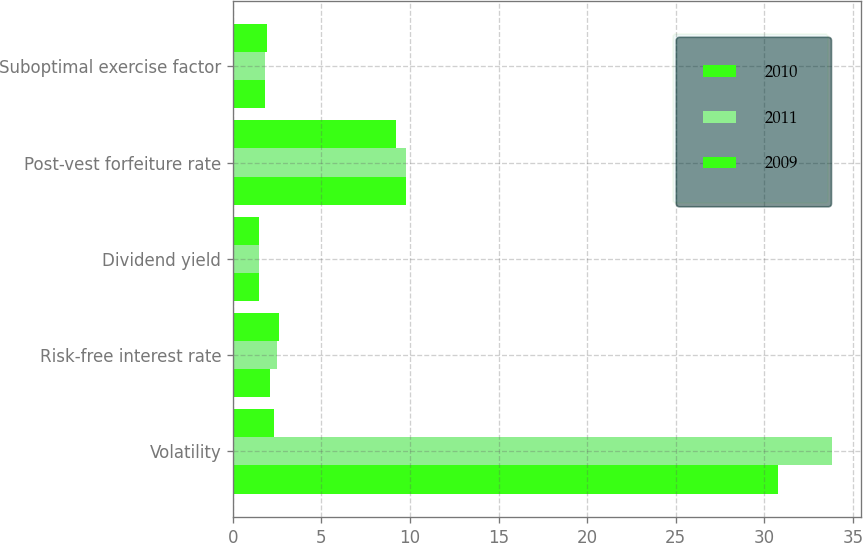Convert chart. <chart><loc_0><loc_0><loc_500><loc_500><stacked_bar_chart><ecel><fcel>Volatility<fcel>Risk-free interest rate<fcel>Dividend yield<fcel>Post-vest forfeiture rate<fcel>Suboptimal exercise factor<nl><fcel>2010<fcel>30.8<fcel>2.1<fcel>1.5<fcel>9.8<fcel>1.8<nl><fcel>2011<fcel>33.8<fcel>2.5<fcel>1.5<fcel>9.8<fcel>1.8<nl><fcel>2009<fcel>2.3<fcel>2.6<fcel>1.5<fcel>9.2<fcel>1.9<nl></chart> 